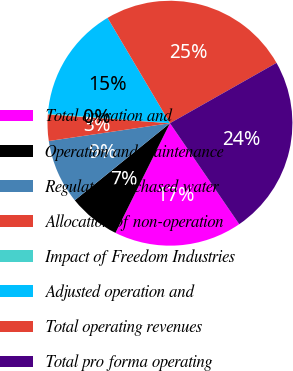Convert chart to OTSL. <chart><loc_0><loc_0><loc_500><loc_500><pie_chart><fcel>Total operation and<fcel>Operation and maintenance<fcel>Regulated purchased water<fcel>Allocation of non-operation<fcel>Impact of Freedom Industries<fcel>Adjusted operation and<fcel>Total operating revenues<fcel>Total pro forma operating<nl><fcel>16.91%<fcel>6.83%<fcel>8.51%<fcel>3.47%<fcel>0.11%<fcel>15.23%<fcel>25.31%<fcel>23.63%<nl></chart> 